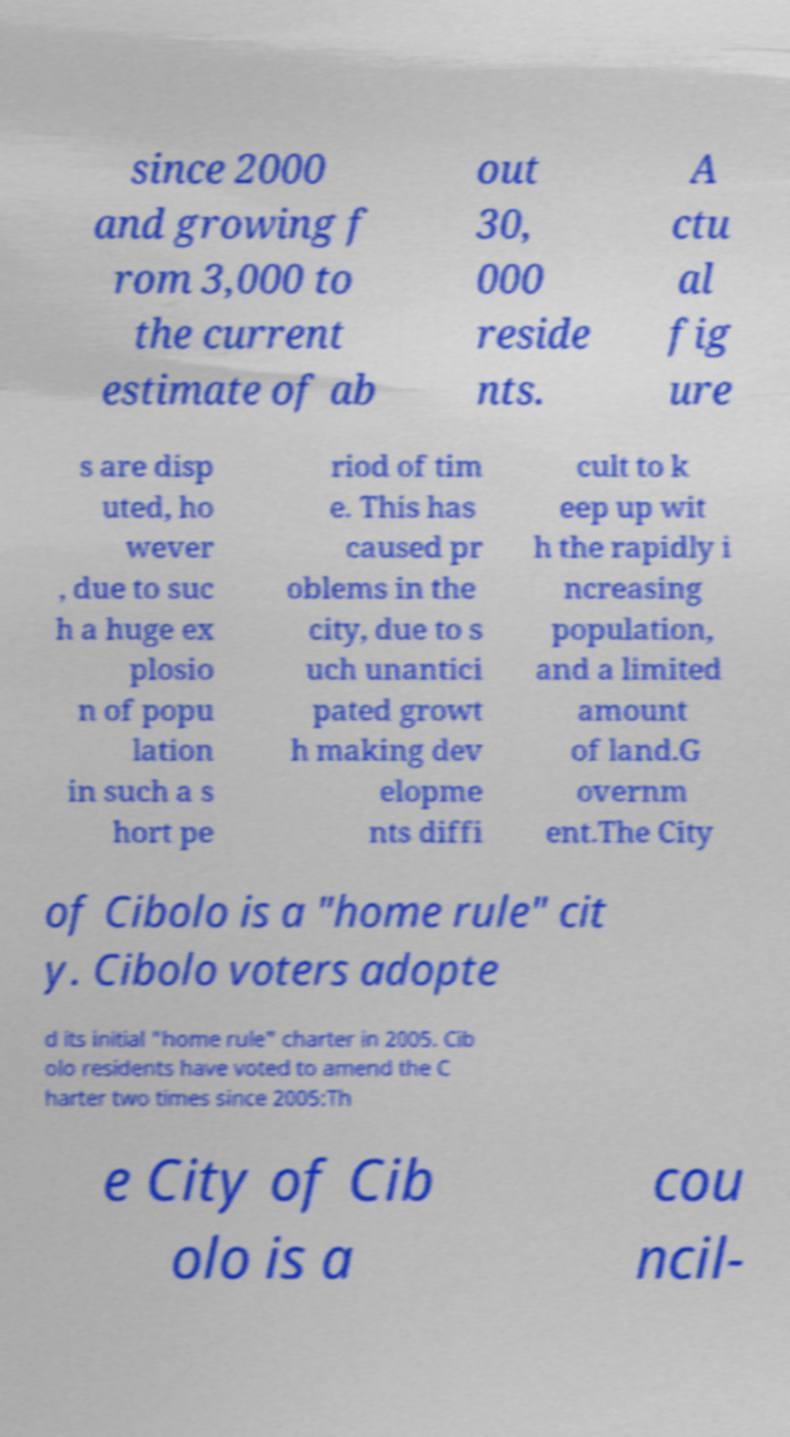Could you extract and type out the text from this image? since 2000 and growing f rom 3,000 to the current estimate of ab out 30, 000 reside nts. A ctu al fig ure s are disp uted, ho wever , due to suc h a huge ex plosio n of popu lation in such a s hort pe riod of tim e. This has caused pr oblems in the city, due to s uch unantici pated growt h making dev elopme nts diffi cult to k eep up wit h the rapidly i ncreasing population, and a limited amount of land.G overnm ent.The City of Cibolo is a "home rule" cit y. Cibolo voters adopte d its initial "home rule" charter in 2005. Cib olo residents have voted to amend the C harter two times since 2005:Th e City of Cib olo is a cou ncil- 